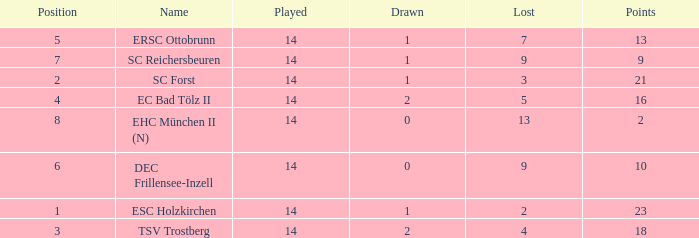How much Drawn has a Lost of 2, and Played smaller than 14? None. 